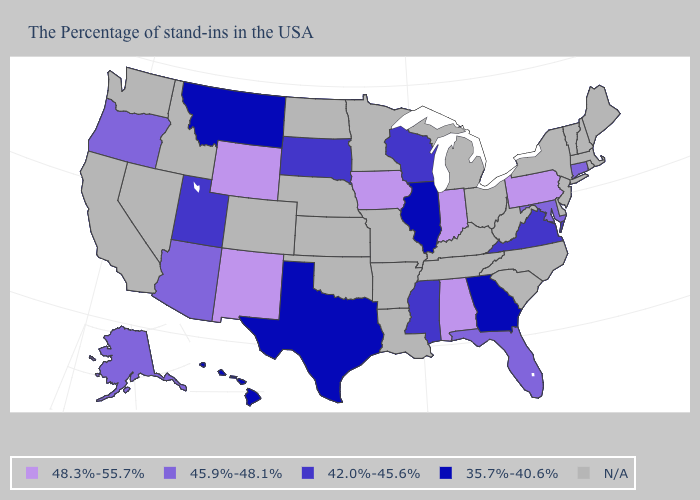Name the states that have a value in the range 35.7%-40.6%?
Keep it brief. Georgia, Illinois, Texas, Montana, Hawaii. Among the states that border South Dakota , which have the lowest value?
Answer briefly. Montana. What is the lowest value in the USA?
Concise answer only. 35.7%-40.6%. Among the states that border Washington , which have the highest value?
Quick response, please. Oregon. What is the lowest value in the USA?
Be succinct. 35.7%-40.6%. What is the value of Wisconsin?
Quick response, please. 42.0%-45.6%. Among the states that border California , which have the highest value?
Concise answer only. Arizona, Oregon. Which states have the lowest value in the USA?
Write a very short answer. Georgia, Illinois, Texas, Montana, Hawaii. What is the value of New Mexico?
Keep it brief. 48.3%-55.7%. Name the states that have a value in the range 45.9%-48.1%?
Concise answer only. Connecticut, Maryland, Florida, Arizona, Oregon, Alaska. Name the states that have a value in the range 48.3%-55.7%?
Give a very brief answer. Pennsylvania, Indiana, Alabama, Iowa, Wyoming, New Mexico. Which states hav the highest value in the South?
Be succinct. Alabama. What is the value of Indiana?
Short answer required. 48.3%-55.7%. What is the highest value in the Northeast ?
Concise answer only. 48.3%-55.7%. 